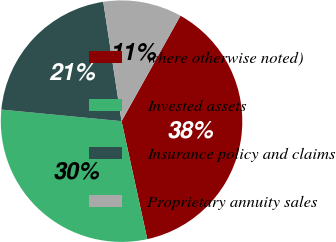Convert chart. <chart><loc_0><loc_0><loc_500><loc_500><pie_chart><fcel>where otherwise noted)<fcel>Invested assets<fcel>Insurance policy and claims<fcel>Proprietary annuity sales<nl><fcel>38.47%<fcel>29.95%<fcel>21.05%<fcel>10.53%<nl></chart> 